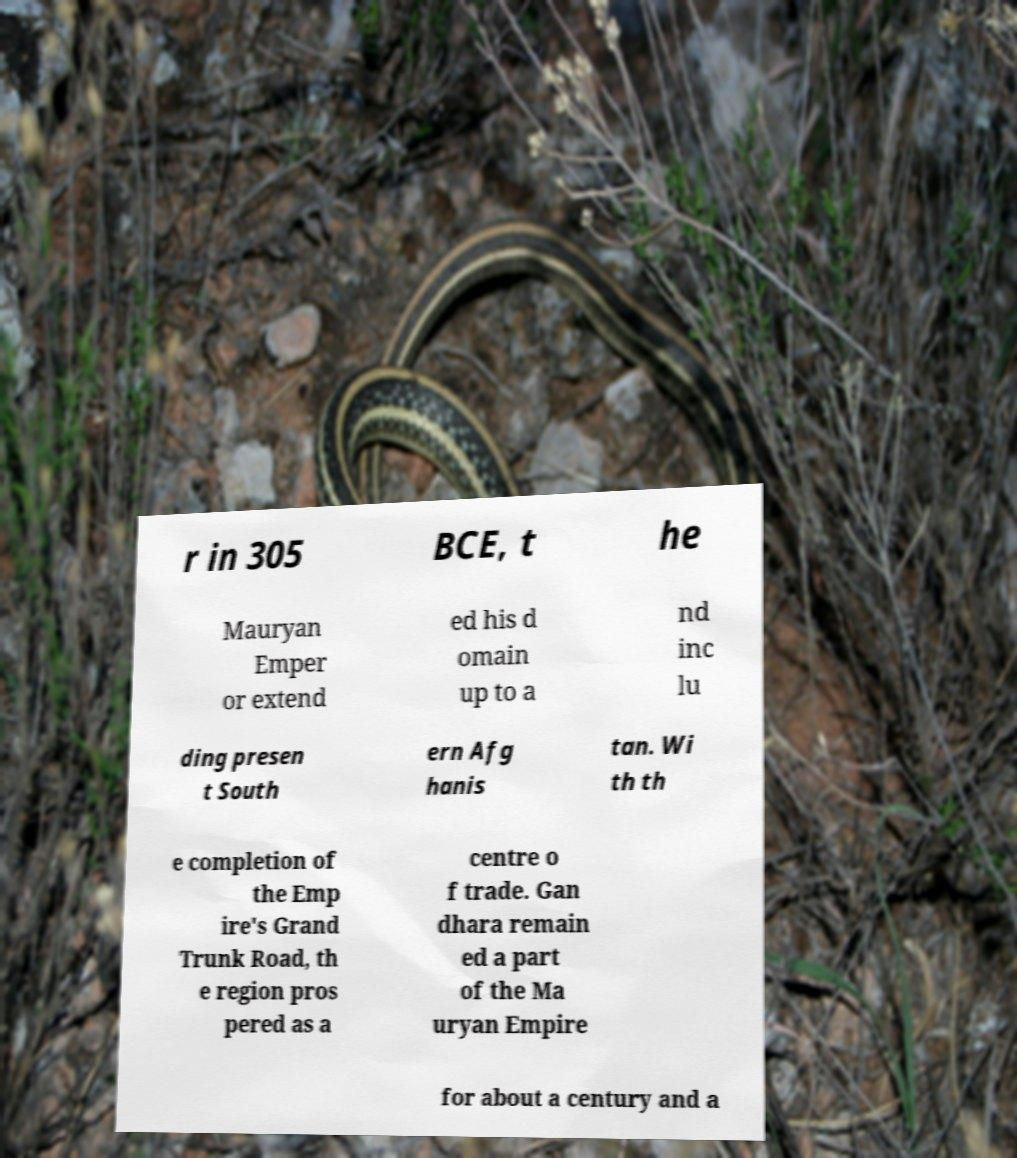Could you assist in decoding the text presented in this image and type it out clearly? r in 305 BCE, t he Mauryan Emper or extend ed his d omain up to a nd inc lu ding presen t South ern Afg hanis tan. Wi th th e completion of the Emp ire's Grand Trunk Road, th e region pros pered as a centre o f trade. Gan dhara remain ed a part of the Ma uryan Empire for about a century and a 